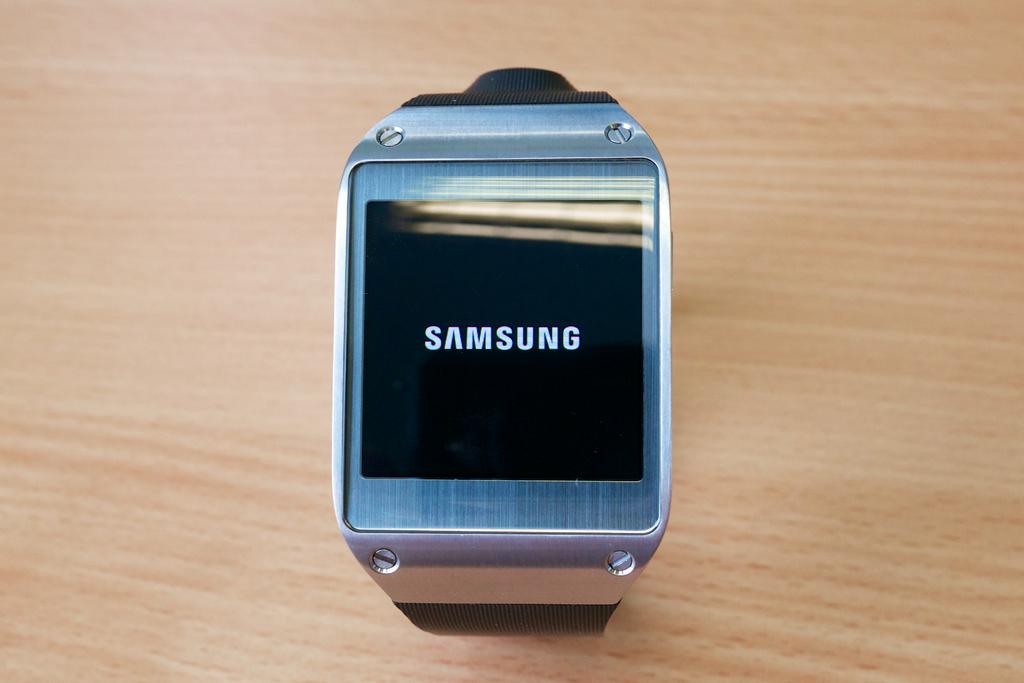<image>
Give a short and clear explanation of the subsequent image. a smart watch with the samsung logo on ttttttttttttttttte screen 